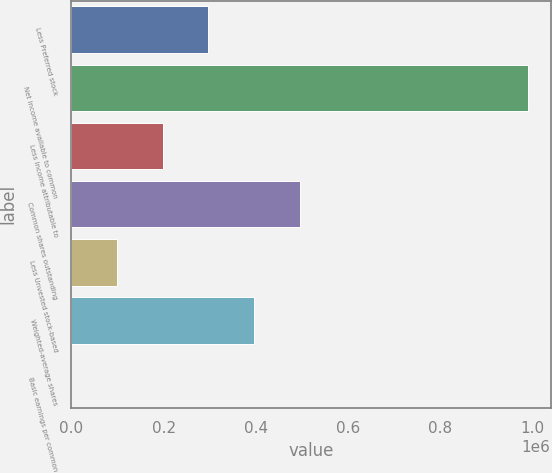Convert chart to OTSL. <chart><loc_0><loc_0><loc_500><loc_500><bar_chart><fcel>Less Preferred stock<fcel>Net income available to common<fcel>Less Income attributable to<fcel>Common shares outstanding<fcel>Less Unvested stock-based<fcel>Weighted-average shares<fcel>Basic earnings per common<nl><fcel>297116<fcel>990368<fcel>198080<fcel>495188<fcel>99043.5<fcel>396152<fcel>7.47<nl></chart> 